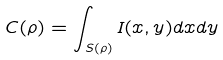Convert formula to latex. <formula><loc_0><loc_0><loc_500><loc_500>C ( \rho ) = \int _ { S ( \rho ) } I ( x , y ) d x d y</formula> 